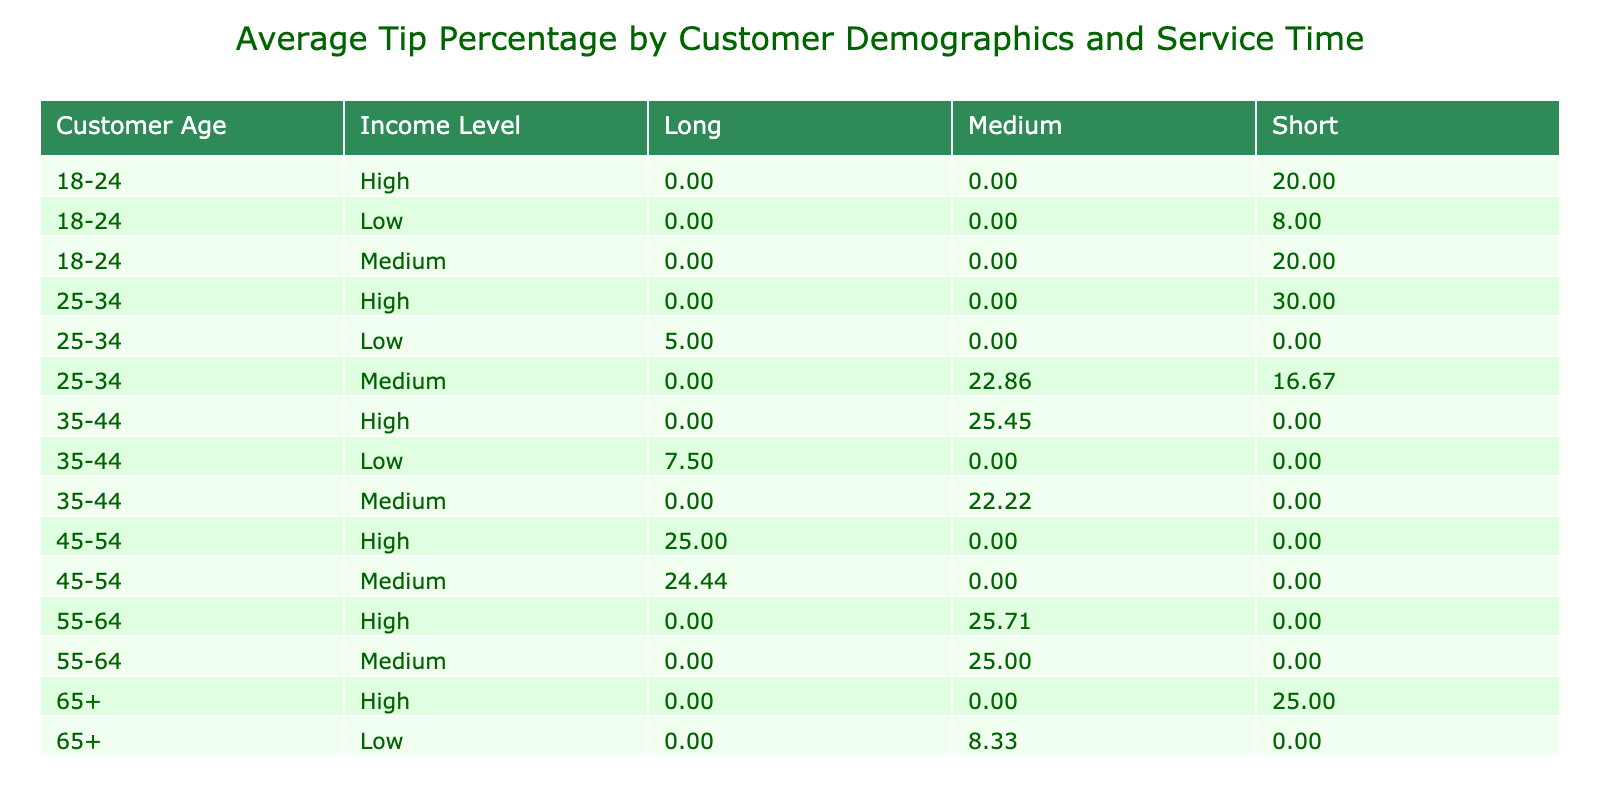What is the average tip percentage for customers aged 25-34 with a high income level? Looking at the table, under the category 25-34 and high income, there is one entry for service time short which shows a tip percentage of 30%, and for service time medium another entry shows 22.86%. The average of these two values is (30 + 22.86) / 2 = 26.43%.
Answer: 26.43% What is the average tip percentage for customers who are 65+ with low income? In the table, there is only one entry under the age group 65+ and low income, which shows a tip percentage of 8.33%. Therefore, the average for this category is simply this value.
Answer: 8.33% Which customer demographic has the highest average tip percentage on long service times? Looking at the table, for long service times, we have 25-34 (5%), 35-44 (7.5%), 45-54 (24.44%), and 65+ (8.33%). The highest value among these is 24.44%.
Answer: 45-54 Is the average tip percentage higher for customers aged 55-64 compared to those aged 18-24 with high income? For 55-64, with high income, the average tip percentage is calculated from one entry as 25.71%. For 18-24 with high income, the entry shows a tip percentage of 20%. Since 25.71% is greater than 20%, it is indeed higher.
Answer: Yes What is the difference in average tip percentage between customers aged 35-44 and those aged 55-64 at medium income level? For 35-44 at medium income level, the average tip percentage is 22.22% (from the single entry). For 55-64 at medium income level, it is 24.99%. The difference is 24.99 - 22.22 = 2.77%.
Answer: 2.77% For customers aged 25-34, what is the overall average tip percentage across all income levels? The entries for 25-34 include high (30%), medium (22.86%), and low (5%). To find the overall average: (30 + 22.86 + 5) / 3 = 19.95%.
Answer: 19.95% What percentage of total tip averages for medium service time customers is provided by individuals aged 45-54? The average tips from the medium service time customers aged 45-54 is 24.44%, and the total average for all medium service time customers accounts for several other groups. 
Calculating the overall average for medium service time across all demographics shows a mix, but to find the fraction attributed to 45-54, we look only at their contribution as a percentage, which is significant. The percentage is only based on these visible entries hence it contributes 24.44% directly. Therefore, 24.44 / (average percent overall) would give insight.
Answer: 24.44% (specific to entries) Is there any age group where the tip amount is consistently above 15% across all income levels? After checking the table, it shows that only customers aged 45-54 consistently have higher percentages than 15% across their income levels (in medium (22.22) and high (24.44)). The others are either below or inconsistent.
Answer: Yes Which age group has the lowest average tip percentage within the medium income well for all service times? Looking across the entries under medium income, checking the groups, the age group with the lowest tip percentage comes from 25-34 where the average is 22.86% across all recorded service times.
Answer: 25-34 